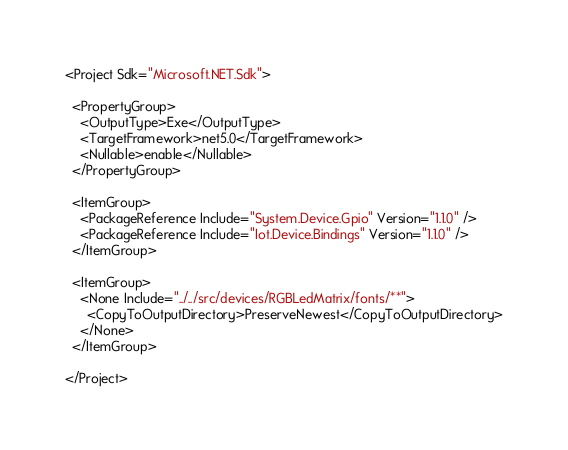Convert code to text. <code><loc_0><loc_0><loc_500><loc_500><_XML_><Project Sdk="Microsoft.NET.Sdk">

  <PropertyGroup>
    <OutputType>Exe</OutputType>
    <TargetFramework>net5.0</TargetFramework>
    <Nullable>enable</Nullable>
  </PropertyGroup>

  <ItemGroup>
    <PackageReference Include="System.Device.Gpio" Version="1.1.0" />
    <PackageReference Include="Iot.Device.Bindings" Version="1.1.0" />
  </ItemGroup>

  <ItemGroup>
    <None Include="../../src/devices/RGBLedMatrix/fonts/**">
      <CopyToOutputDirectory>PreserveNewest</CopyToOutputDirectory>
    </None>
  </ItemGroup>

</Project>
</code> 